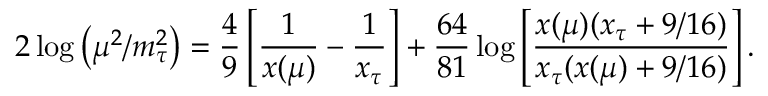<formula> <loc_0><loc_0><loc_500><loc_500>2 \log \left ( \mu ^ { 2 } / m _ { \tau } ^ { 2 } \right ) = \frac { 4 } { 9 } \left [ \frac { 1 } { x ( \mu ) } - \frac { 1 } { x _ { \tau } } \right ] + \frac { 6 4 } { 8 1 } \log \left [ \frac { x ( \mu ) ( x _ { \tau } + 9 / 1 6 ) } { x _ { \tau } ( x ( \mu ) + 9 / 1 6 ) } \right ] .</formula> 